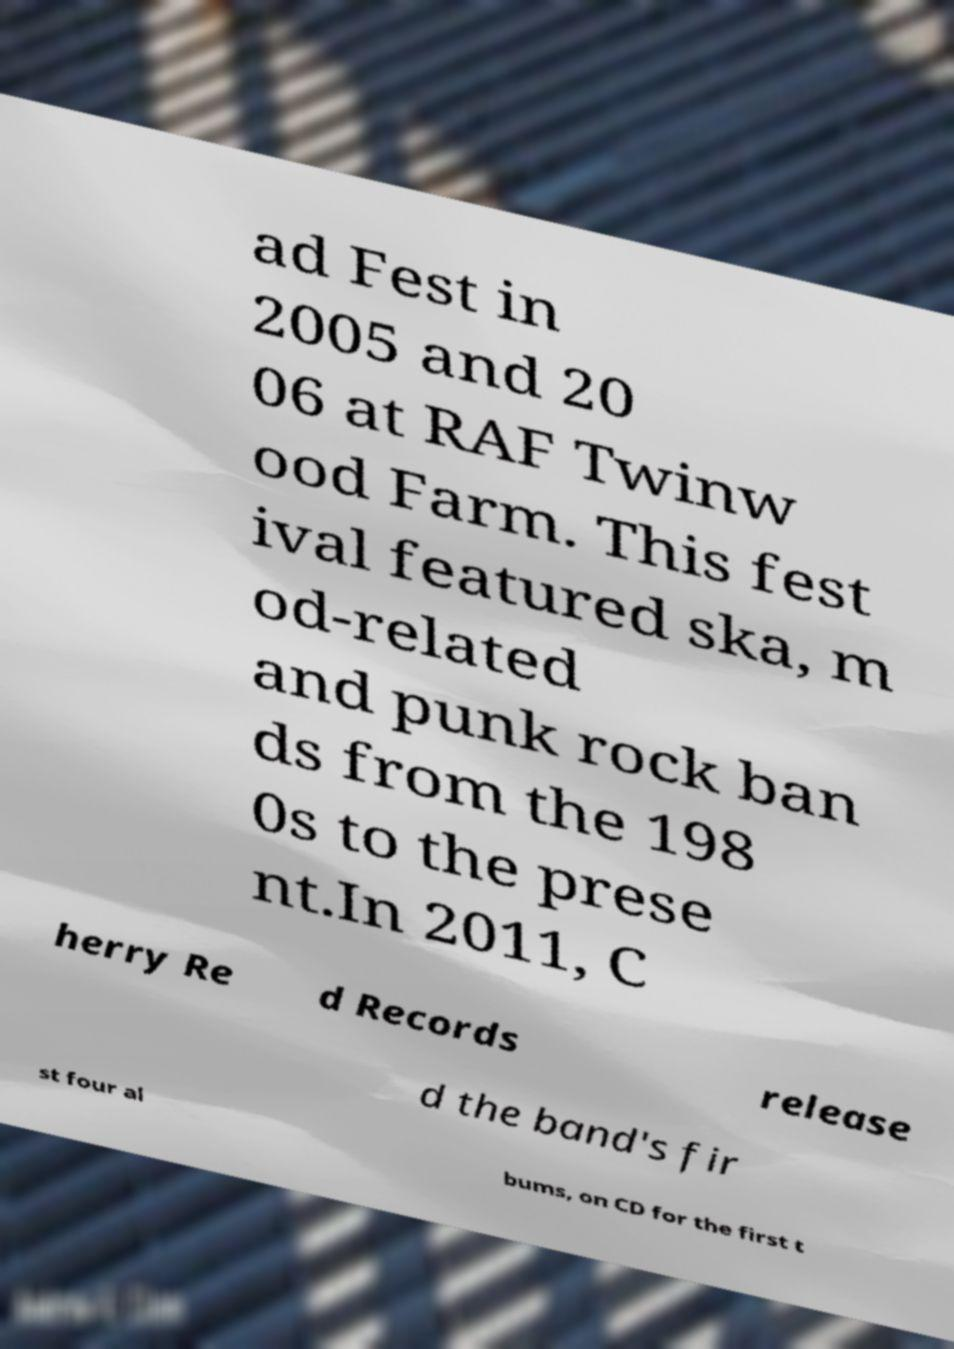I need the written content from this picture converted into text. Can you do that? ad Fest in 2005 and 20 06 at RAF Twinw ood Farm. This fest ival featured ska, m od-related and punk rock ban ds from the 198 0s to the prese nt.In 2011, C herry Re d Records release d the band's fir st four al bums, on CD for the first t 